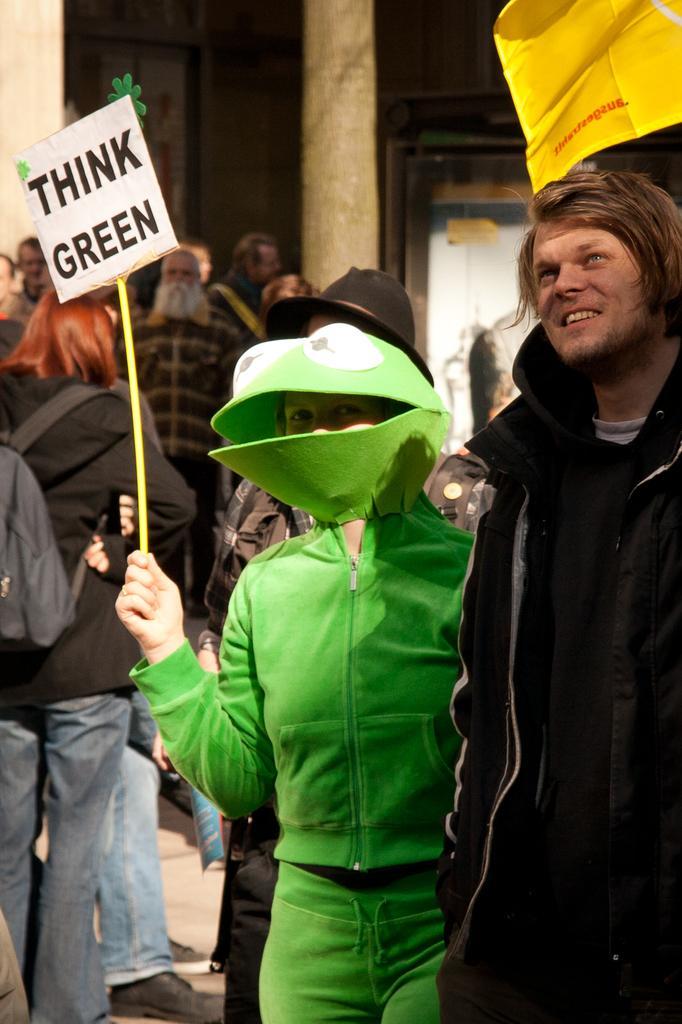In one or two sentences, can you explain what this image depicts? In this image I can see number of people are standing. I can see most of them are wearing jackets and here I can see one of them is holding a board and on it I can see something is written. I can also see this image is little bit blurry from background. 